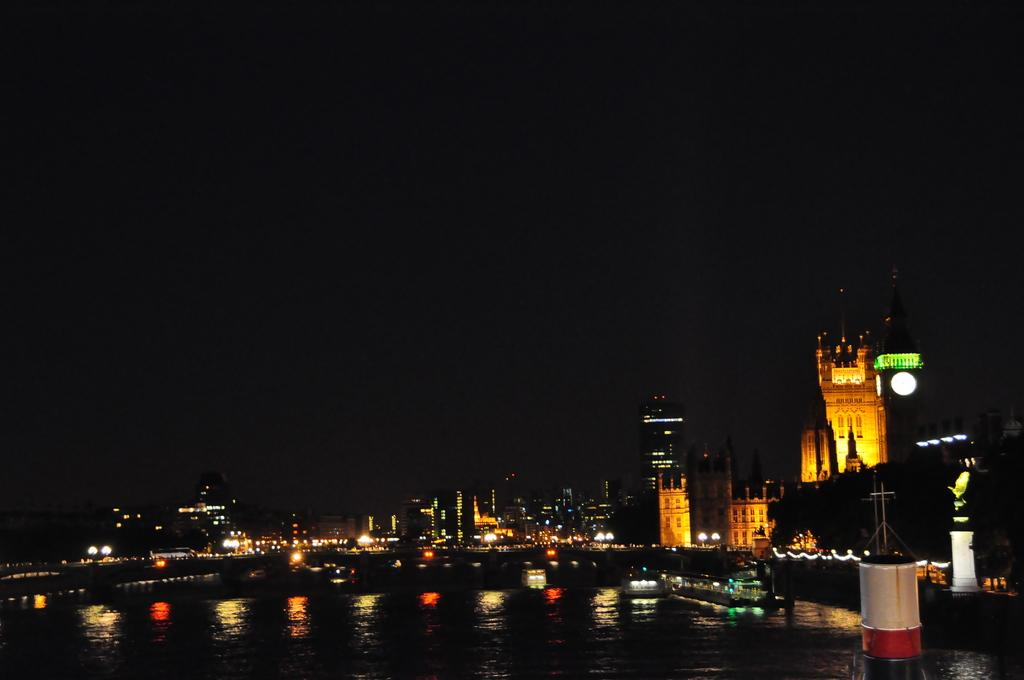What is the primary element in the image? There is water in the image. What is happening on the water? There are ships moving on the water. What can be seen in the background of the image? There are buildings and lights visible in the background of the image. How would you describe the sky in the background of the image? The sky is dark in the background of the image. What suggestion is being made by the waste in the image? There is no waste present in the image, so no suggestion can be made. 